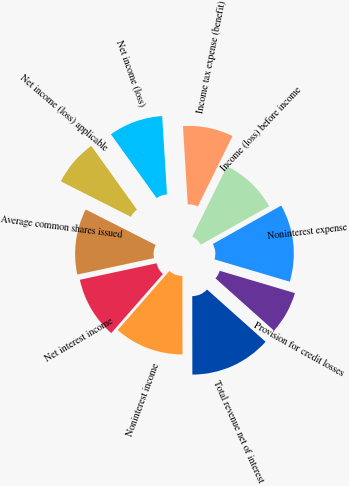<chart> <loc_0><loc_0><loc_500><loc_500><pie_chart><fcel>Net interest income<fcel>Noninterest income<fcel>Total revenue net of interest<fcel>Provision for credit losses<fcel>Noninterest expense<fcel>Income (loss) before income<fcel>Income tax expense (benefit)<fcel>Net income (loss)<fcel>Net income (loss) applicable<fcel>Average common shares issued<nl><fcel>10.19%<fcel>11.46%<fcel>13.38%<fcel>7.01%<fcel>12.74%<fcel>9.55%<fcel>8.28%<fcel>8.92%<fcel>7.64%<fcel>10.83%<nl></chart> 